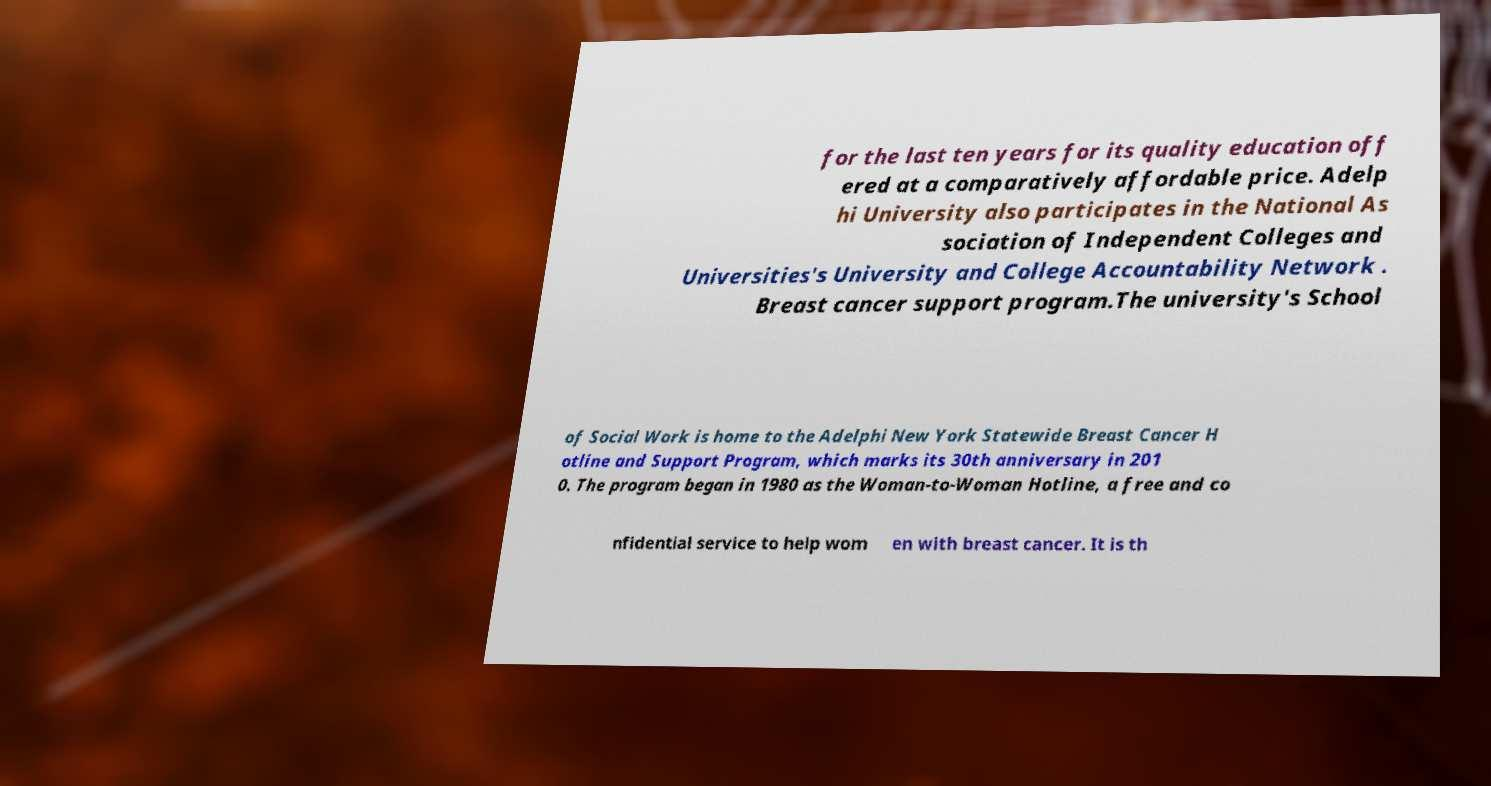Please identify and transcribe the text found in this image. for the last ten years for its quality education off ered at a comparatively affordable price. Adelp hi University also participates in the National As sociation of Independent Colleges and Universities's University and College Accountability Network . Breast cancer support program.The university's School of Social Work is home to the Adelphi New York Statewide Breast Cancer H otline and Support Program, which marks its 30th anniversary in 201 0. The program began in 1980 as the Woman-to-Woman Hotline, a free and co nfidential service to help wom en with breast cancer. It is th 